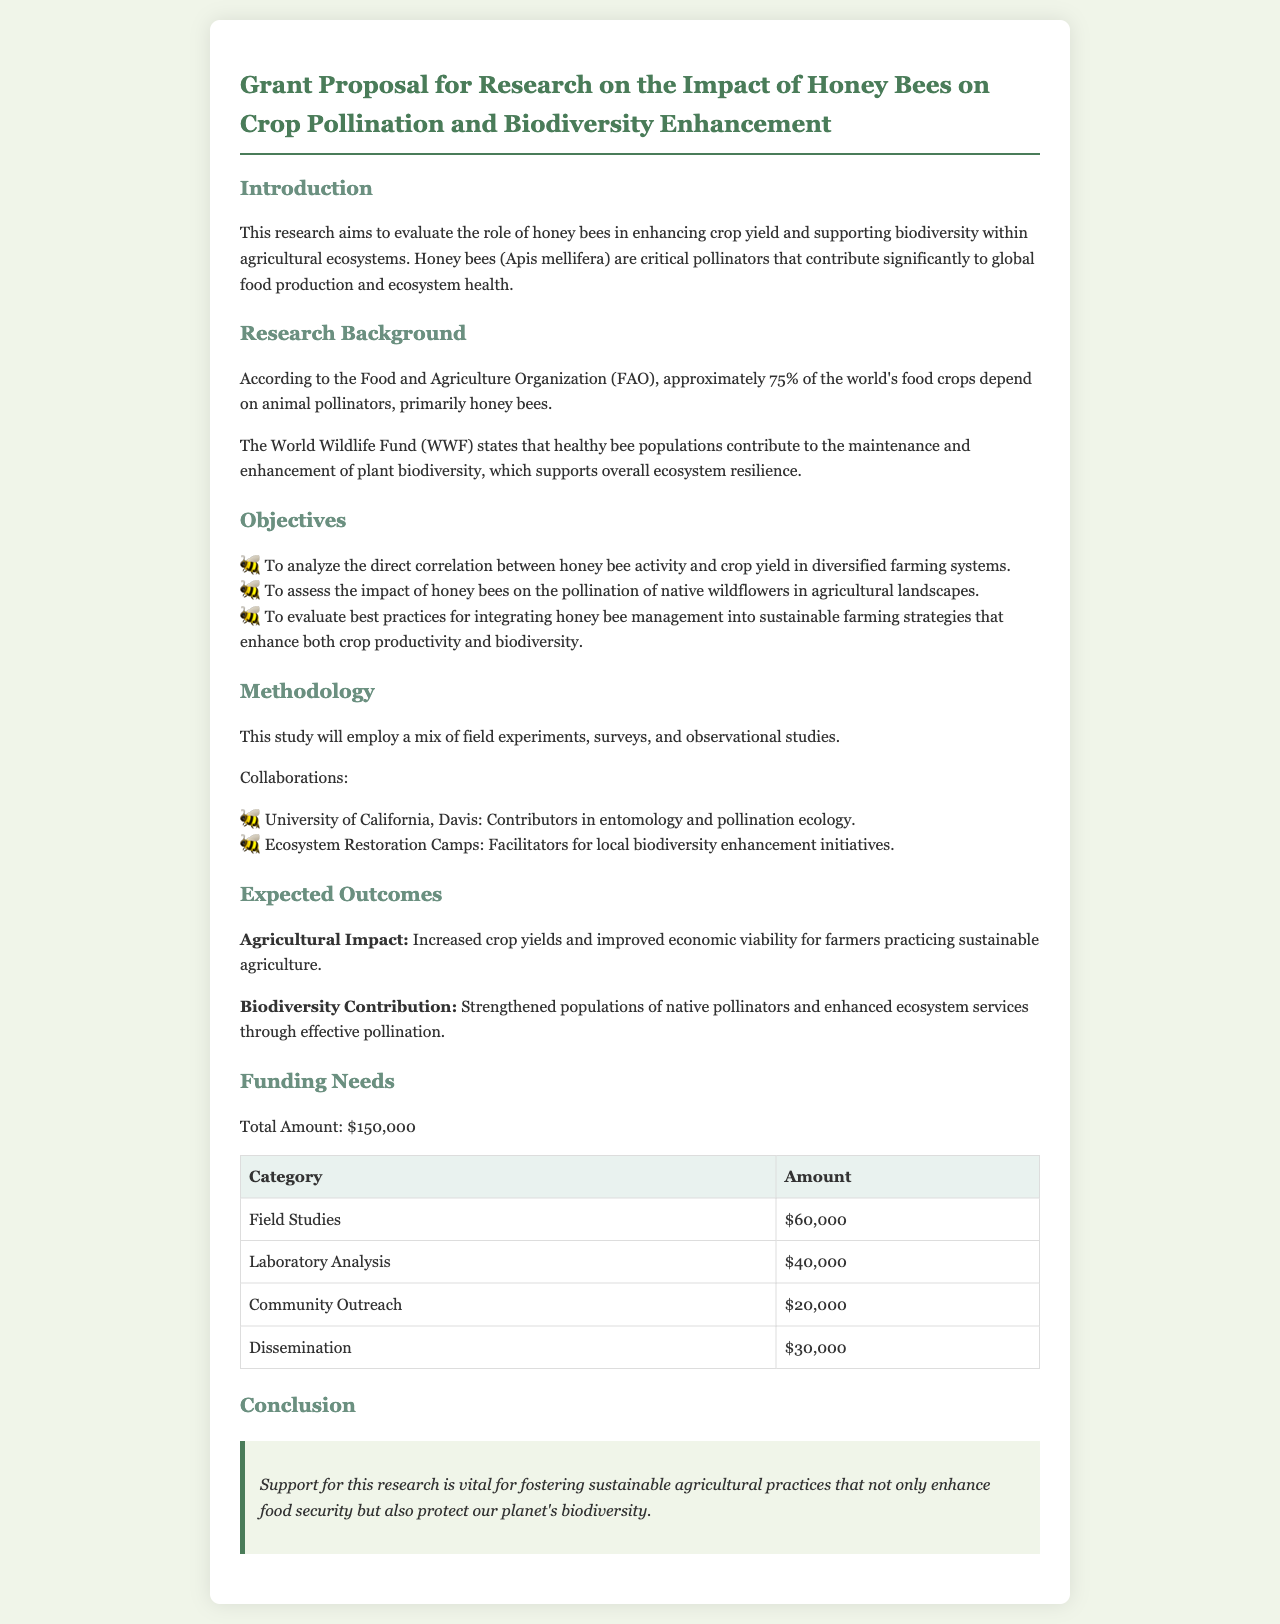What is the total funding needed for the research? The total funding required for the research, as stated in the document, is $150,000.
Answer: $150,000 Which organization is mentioned as a collaborator for local biodiversity enhancement initiatives? The document states that Ecosystem Restoration Camps is a collaborator for local biodiversity enhancement initiatives.
Answer: Ecosystem Restoration Camps What is one of the objectives of the research? The document lists several objectives, one of which is to analyze the direct correlation between honey bee activity and crop yield in diversified farming systems.
Answer: Analyze the direct correlation between honey bee activity and crop yield What is the main focus of this research? The primary aim of the research is to evaluate the role of honey bees in enhancing crop yield and supporting biodiversity within agricultural ecosystems.
Answer: Evaluate the role of honey bees in enhancing crop yield How much funding is allocated for community outreach? The document specifies that $20,000 is allocated for community outreach in the funding table.
Answer: $20,000 Who are the contributors in entomology and pollination ecology mentioned in the document? According to the document, the University of California, Davis is mentioned as the contributor in entomology and pollination ecology.
Answer: University of California, Davis What impact does the research aim to have on agricultural practices? The document states that support for this research is vital for fostering sustainable agricultural practices that enhance food security.
Answer: Enhance food security What is the expected agricultural outcome of the research? The expected outcome mentioned in the document is increased crop yields and improved economic viability for farmers practicing sustainable agriculture.
Answer: Increased crop yields and improved economic viability for farmers 